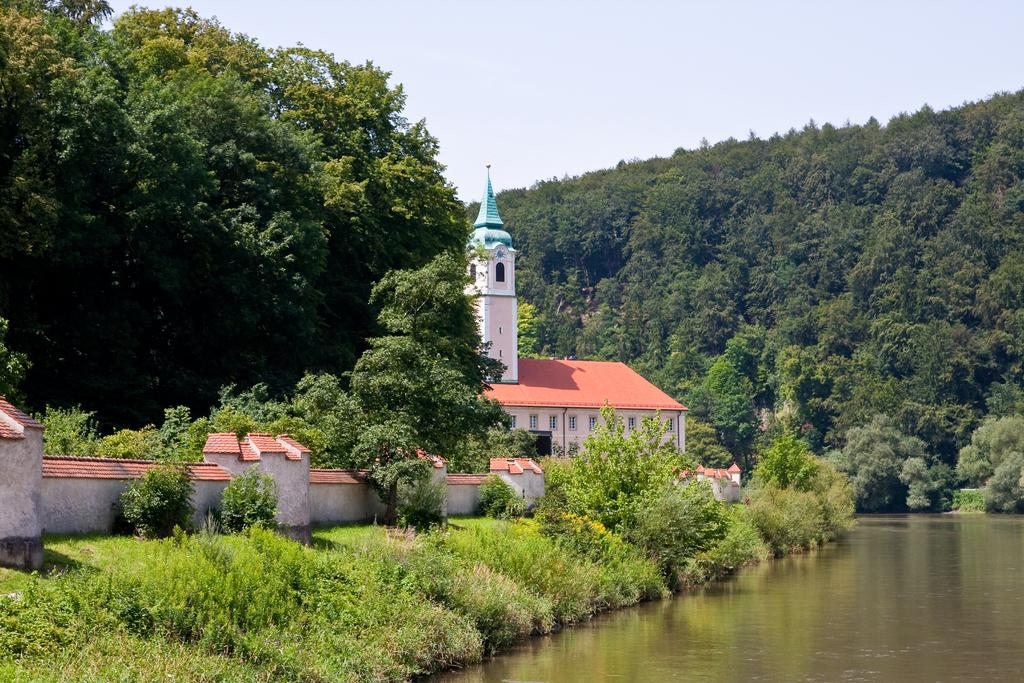What can be seen on the right side of the image? There is water on the right side of the image. What is located near the water? There are plants near the water. What architectural feature is present in the image? There is a wall in the image. What can be seen in the background of the image? There is a building with windows, trees, and the sky visible in the background. What type of dress is being worn by the noise in the image? There is no noise or dress present in the image. How many minutes does it take for the minute to pass in the image? There is no concept of time passing in the image, so it is not possible to determine how many minutes pass. 